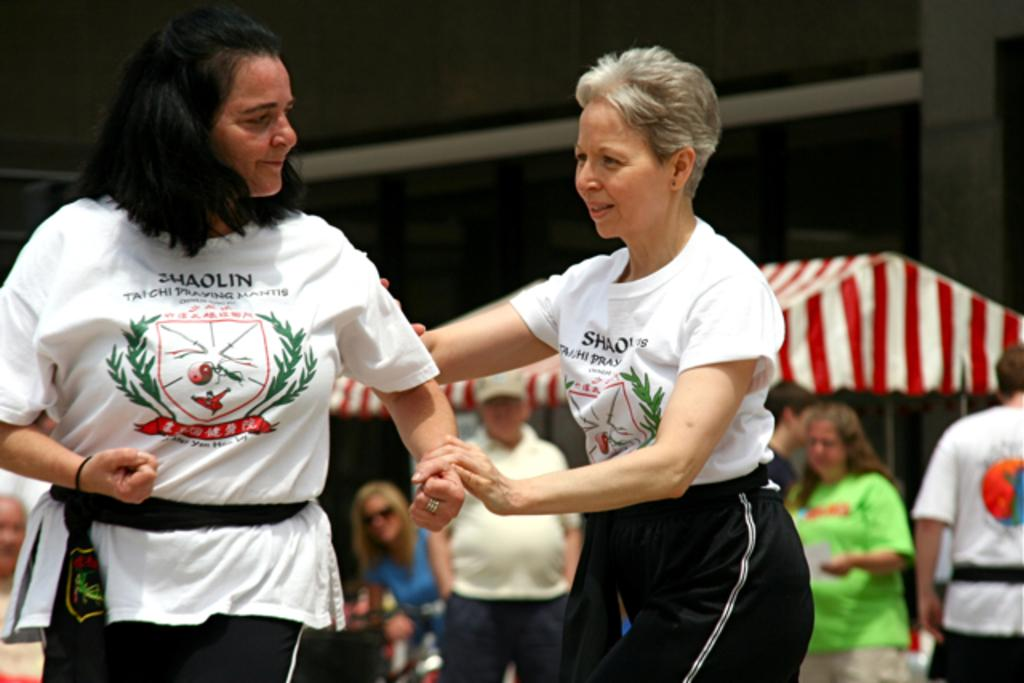How many people are visible in the image? There are two persons standing in the image. What can be seen in the background of the image? There is a group of people standing in the background of the image, as well as a canopy tent. How many rabbits can be seen interacting with the canopy tent in the image? There are no rabbits present in the image, and therefore no such interaction can be observed. 